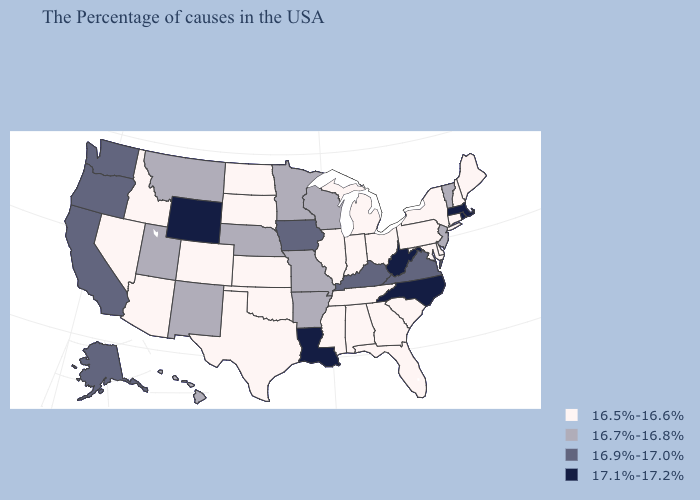Does West Virginia have the lowest value in the USA?
Give a very brief answer. No. Name the states that have a value in the range 17.1%-17.2%?
Quick response, please. Massachusetts, Rhode Island, North Carolina, West Virginia, Louisiana, Wyoming. What is the value of Minnesota?
Concise answer only. 16.7%-16.8%. Name the states that have a value in the range 16.5%-16.6%?
Answer briefly. Maine, New Hampshire, Connecticut, New York, Delaware, Maryland, Pennsylvania, South Carolina, Ohio, Florida, Georgia, Michigan, Indiana, Alabama, Tennessee, Illinois, Mississippi, Kansas, Oklahoma, Texas, South Dakota, North Dakota, Colorado, Arizona, Idaho, Nevada. Name the states that have a value in the range 16.7%-16.8%?
Keep it brief. Vermont, New Jersey, Wisconsin, Missouri, Arkansas, Minnesota, Nebraska, New Mexico, Utah, Montana, Hawaii. What is the lowest value in the West?
Answer briefly. 16.5%-16.6%. What is the lowest value in states that border Minnesota?
Concise answer only. 16.5%-16.6%. What is the lowest value in the West?
Answer briefly. 16.5%-16.6%. What is the lowest value in the Northeast?
Be succinct. 16.5%-16.6%. Name the states that have a value in the range 17.1%-17.2%?
Give a very brief answer. Massachusetts, Rhode Island, North Carolina, West Virginia, Louisiana, Wyoming. What is the value of Delaware?
Write a very short answer. 16.5%-16.6%. Name the states that have a value in the range 17.1%-17.2%?
Short answer required. Massachusetts, Rhode Island, North Carolina, West Virginia, Louisiana, Wyoming. What is the value of North Dakota?
Keep it brief. 16.5%-16.6%. What is the lowest value in the USA?
Give a very brief answer. 16.5%-16.6%. Which states have the lowest value in the MidWest?
Be succinct. Ohio, Michigan, Indiana, Illinois, Kansas, South Dakota, North Dakota. 